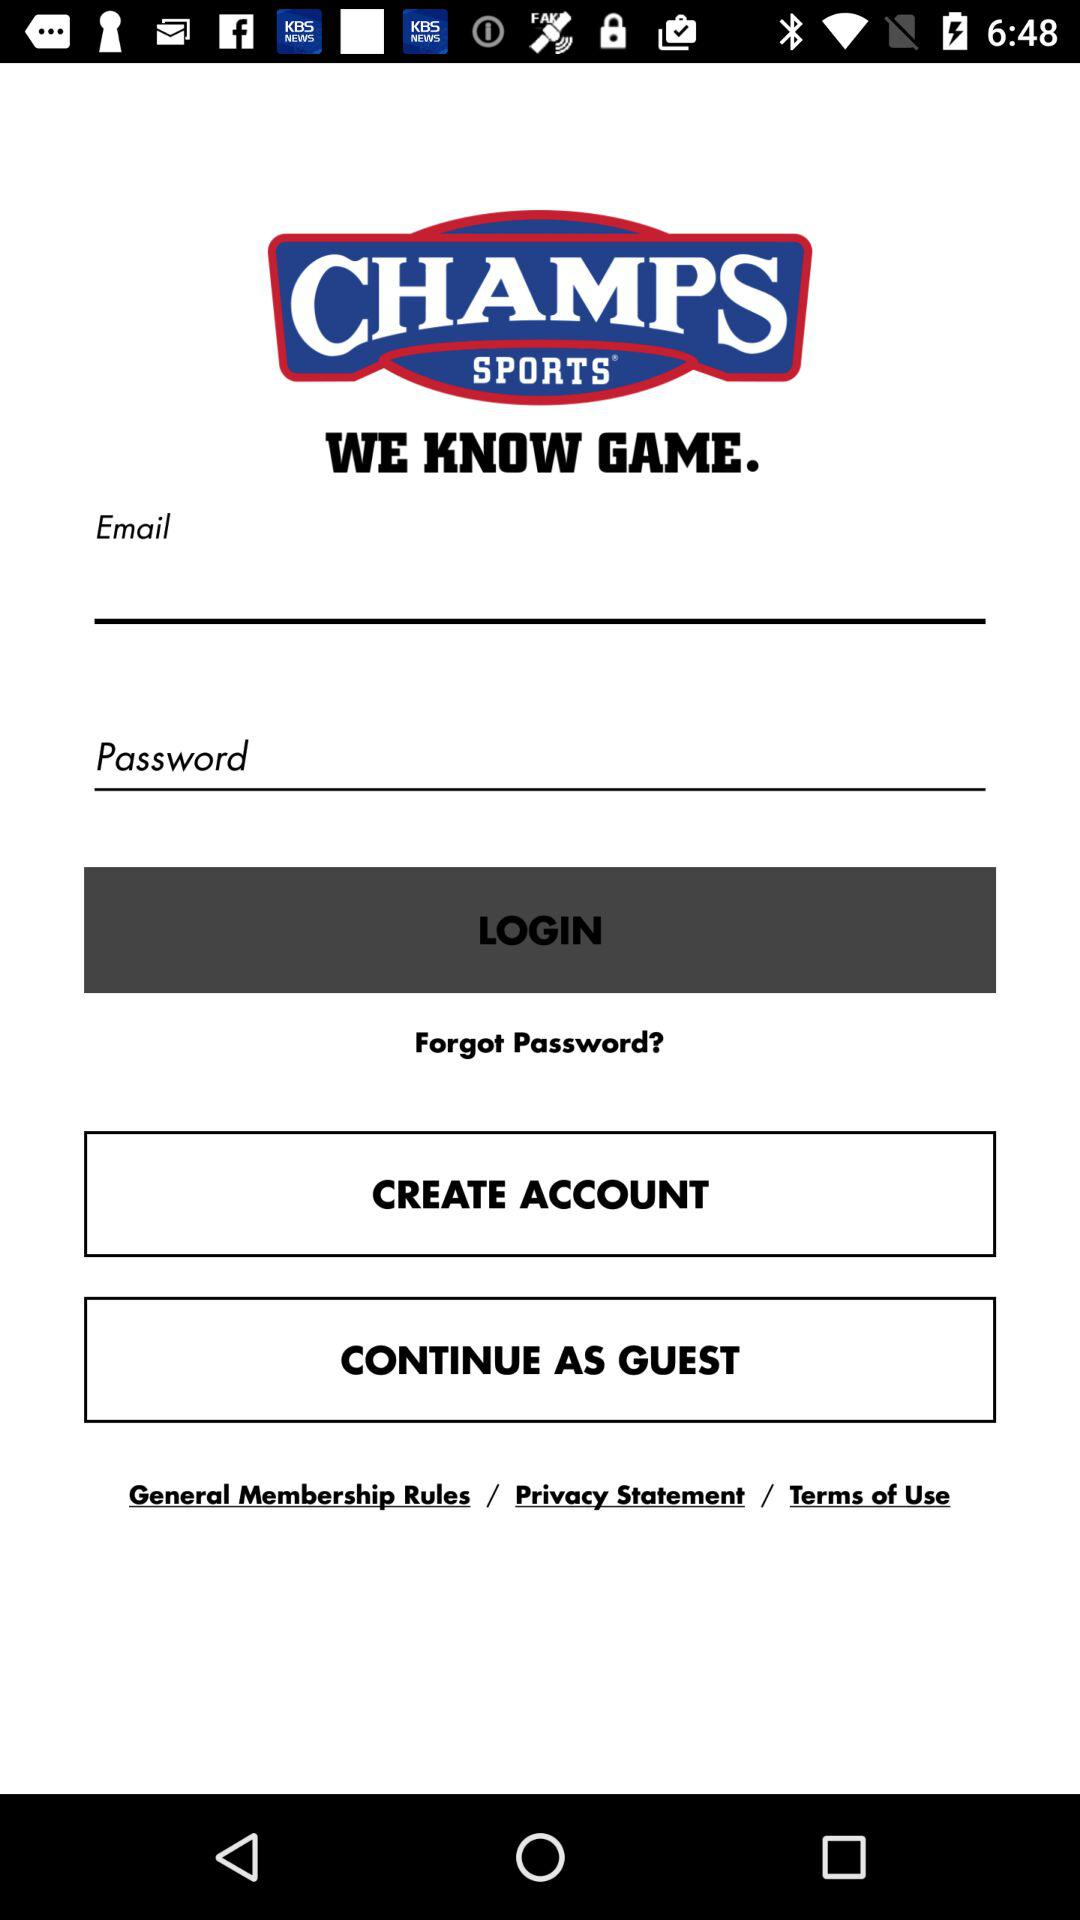What is the name of the application? The name of the application is "CHAMPS SPORTS". 